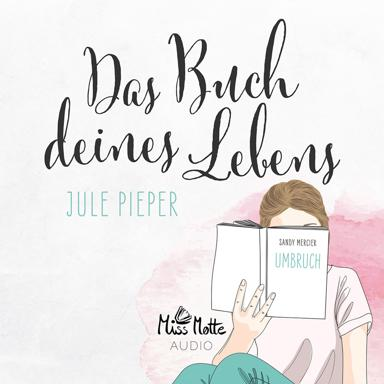How does the design and style of the book cover contribute to the overall mood of the image? The book cover features soft pastel colors and a minimalistic design, which adds to the serene and calming ambiance of the image, reflecting perhaps the gentle and introspective nature of the book's content. 